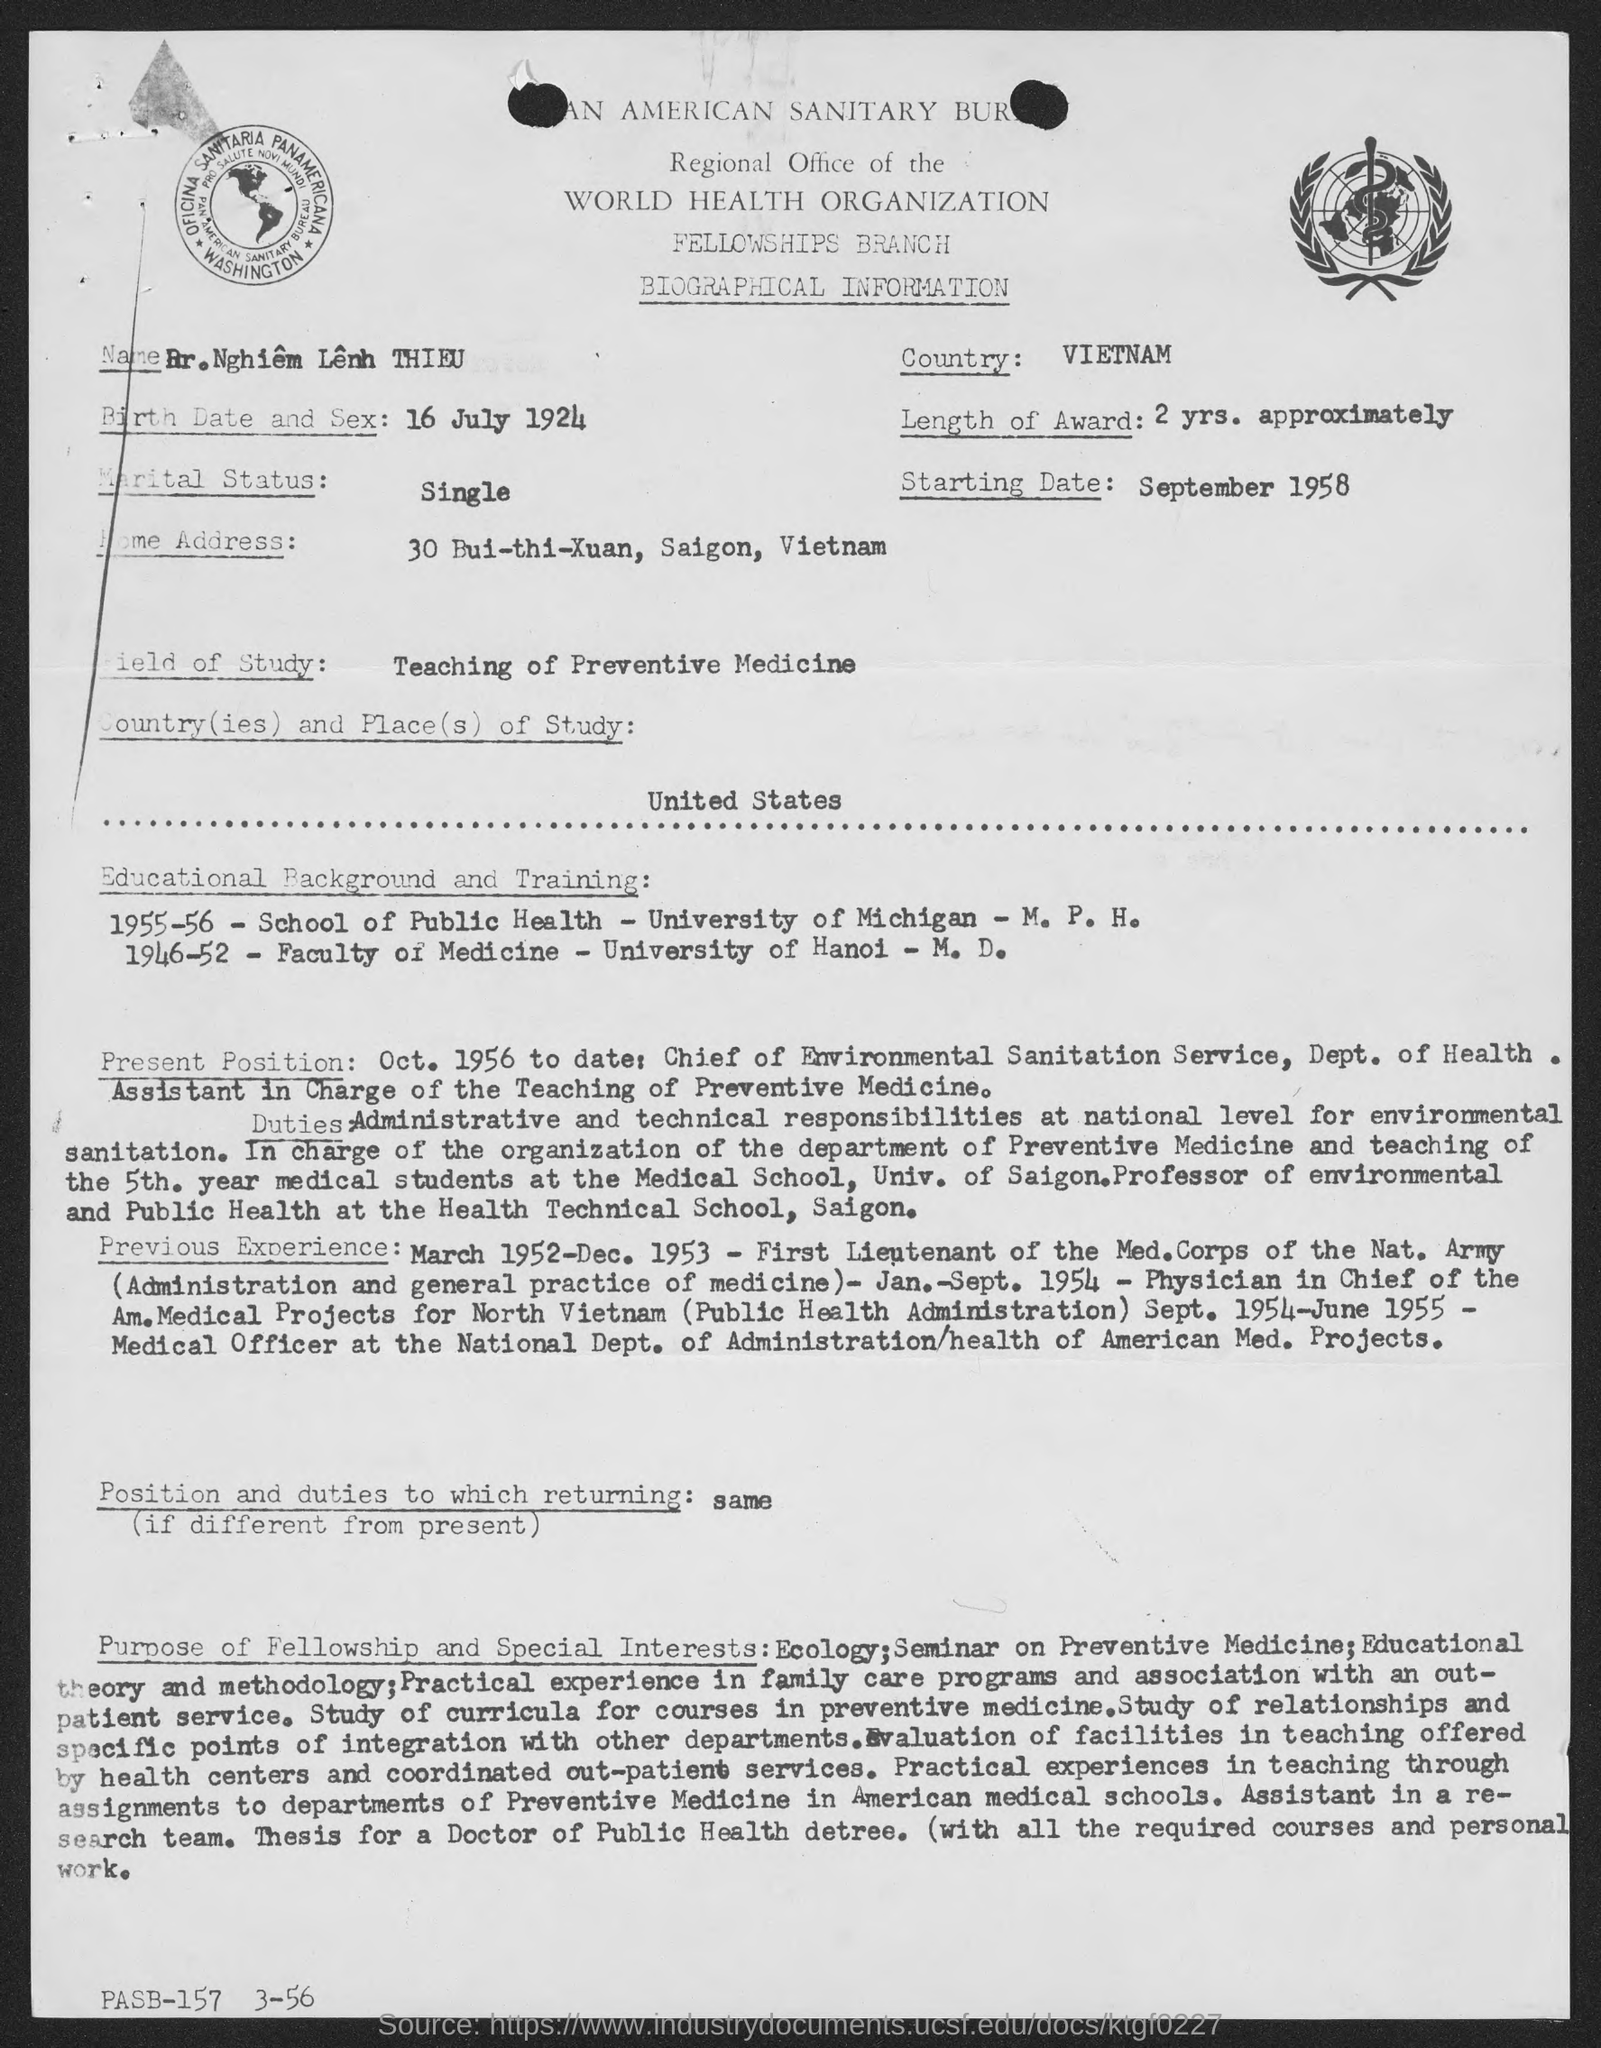What is the birth date of Dr. Nghiem Lenh THIEU?
Keep it short and to the point. 16 JULY 1924. Which country does Dr. Nghiem Lenh THIEU belongs to?
Your response must be concise. VIETNAM. What is the marital status of Dr. Nghiem Lenh THIEU?
Your response must be concise. Single. What is the starting date given in the document?
Your response must be concise. SEPTEMBER 1958. Which is the field of study of Dr. Nghiem Lenh THIEU mentioned in the document?
Your answer should be compact. Teaching of Preventive Medicine. In which university, Dr. Nghiem Lenh THIEU completed the M.D. degree?
Provide a short and direct response. University of Hanoi. During which year, Dr. Nghiem Lenh THIEU had done M.P.H. Degree from the University of Michigan?
Your answer should be compact. 1955-56. What is the home address of Dr. Nghiem Lenh THIEU given in the document?
Offer a very short reply. 30 BUI-THI-XUAN, SAIGON, VIETNAM. 